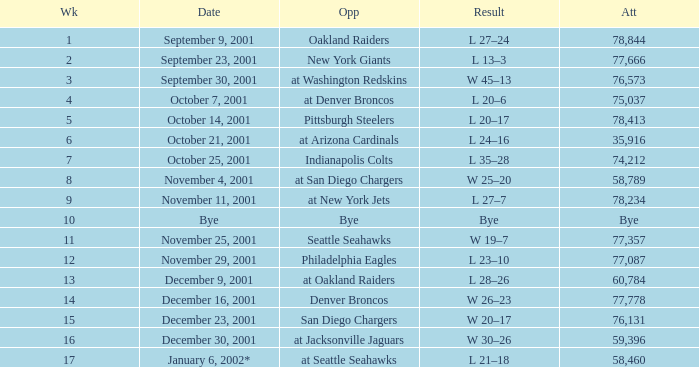What week is a bye week? 10.0. 